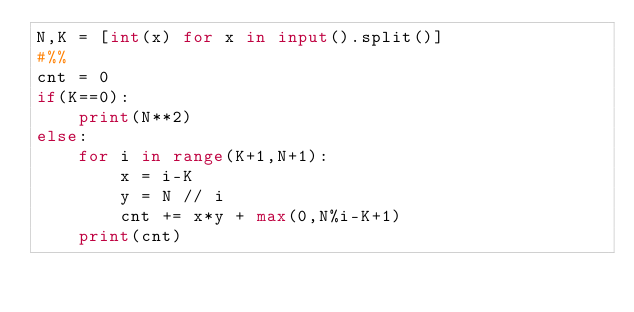<code> <loc_0><loc_0><loc_500><loc_500><_Python_>N,K = [int(x) for x in input().split()]
#%%
cnt = 0
if(K==0):
    print(N**2)
else:
    for i in range(K+1,N+1):
        x = i-K
        y = N // i
        cnt += x*y + max(0,N%i-K+1)
    print(cnt)
</code> 